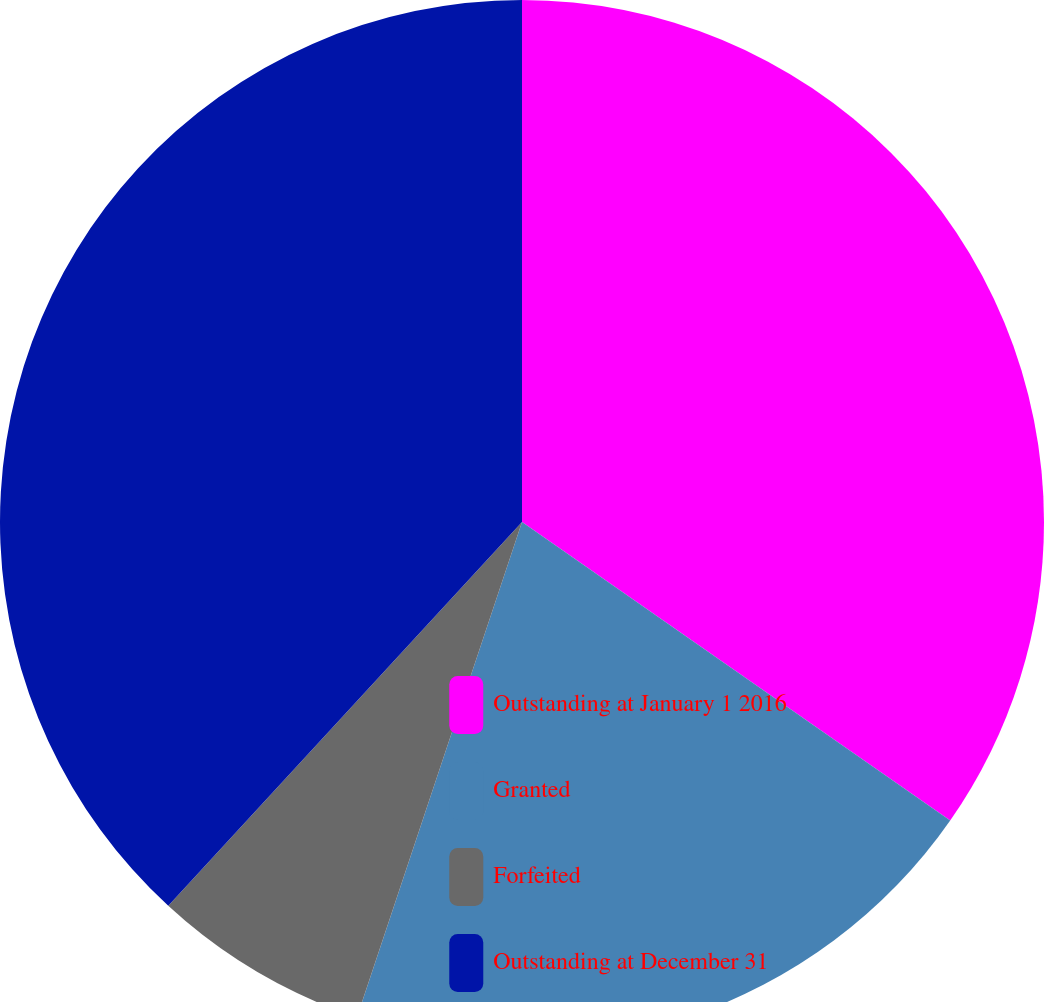<chart> <loc_0><loc_0><loc_500><loc_500><pie_chart><fcel>Outstanding at January 1 2016<fcel>Granted<fcel>Forfeited<fcel>Outstanding at December 31<nl><fcel>34.69%<fcel>20.43%<fcel>6.73%<fcel>38.15%<nl></chart> 